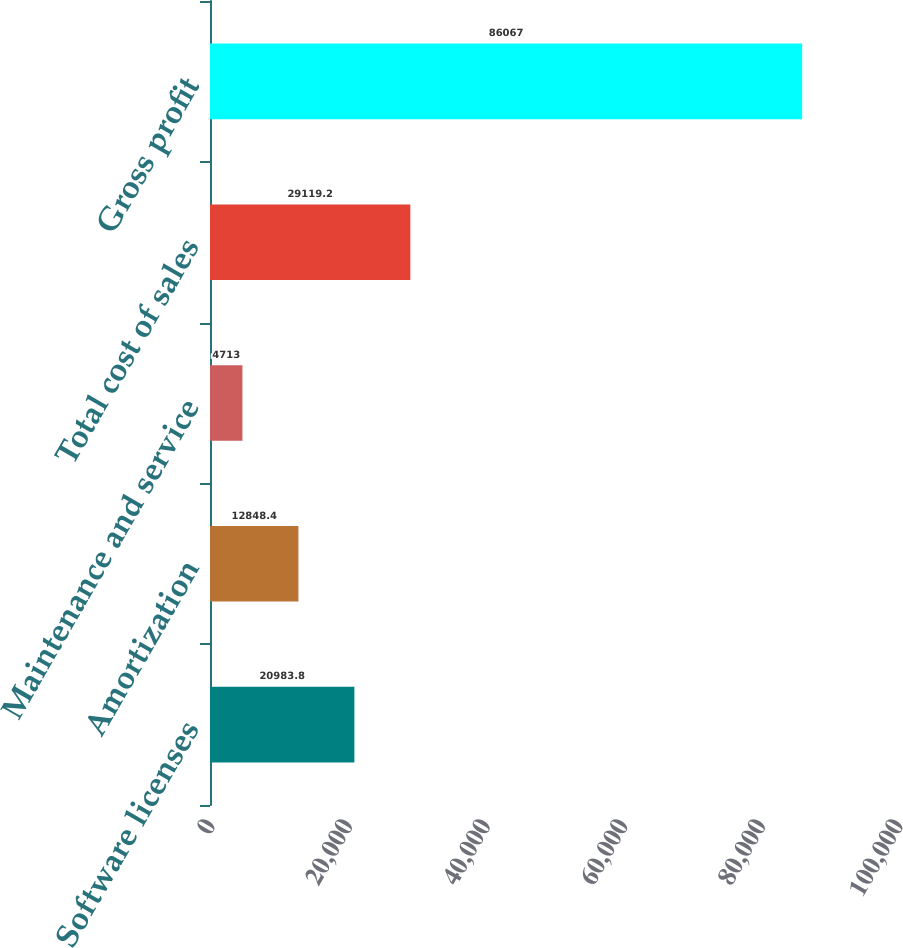Convert chart. <chart><loc_0><loc_0><loc_500><loc_500><bar_chart><fcel>Software licenses<fcel>Amortization<fcel>Maintenance and service<fcel>Total cost of sales<fcel>Gross profit<nl><fcel>20983.8<fcel>12848.4<fcel>4713<fcel>29119.2<fcel>86067<nl></chart> 